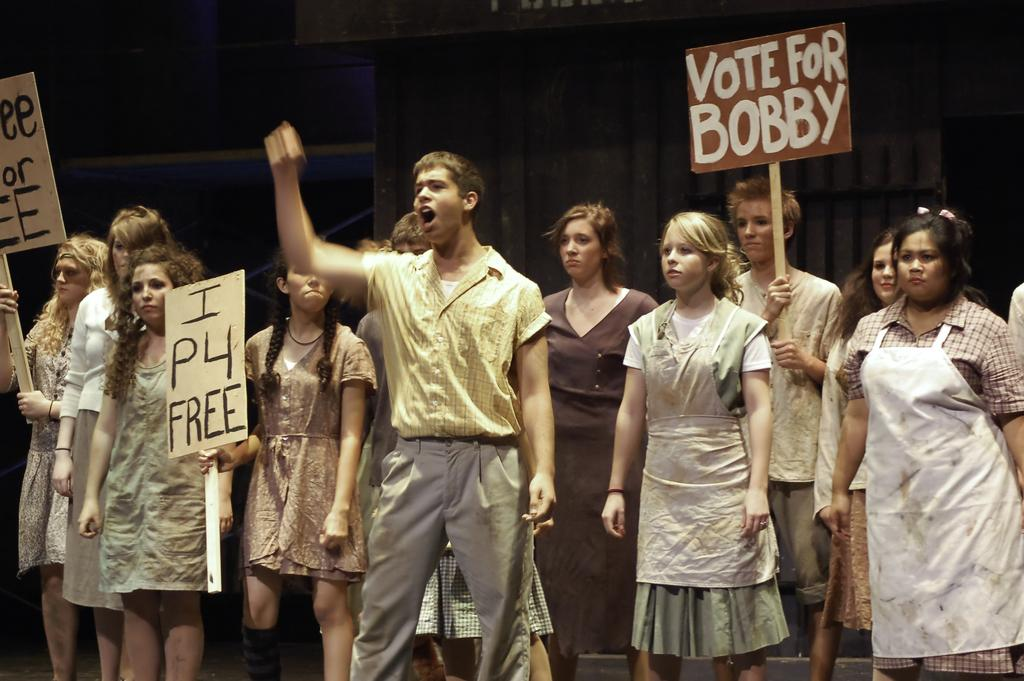How many people are in the image? There is a group of people in the image. What are some of the people holding in the image? Some of the people are holding boards in the image. What might the people holding boards be doing? The people holding boards may be protesting against something. What type of hearing is taking place in the image? There is no hearing taking place in the image; it features a group of people holding boards, which may indicate a protest. Can you see any books in the image? There is no mention of books in the image, only people holding boards. 